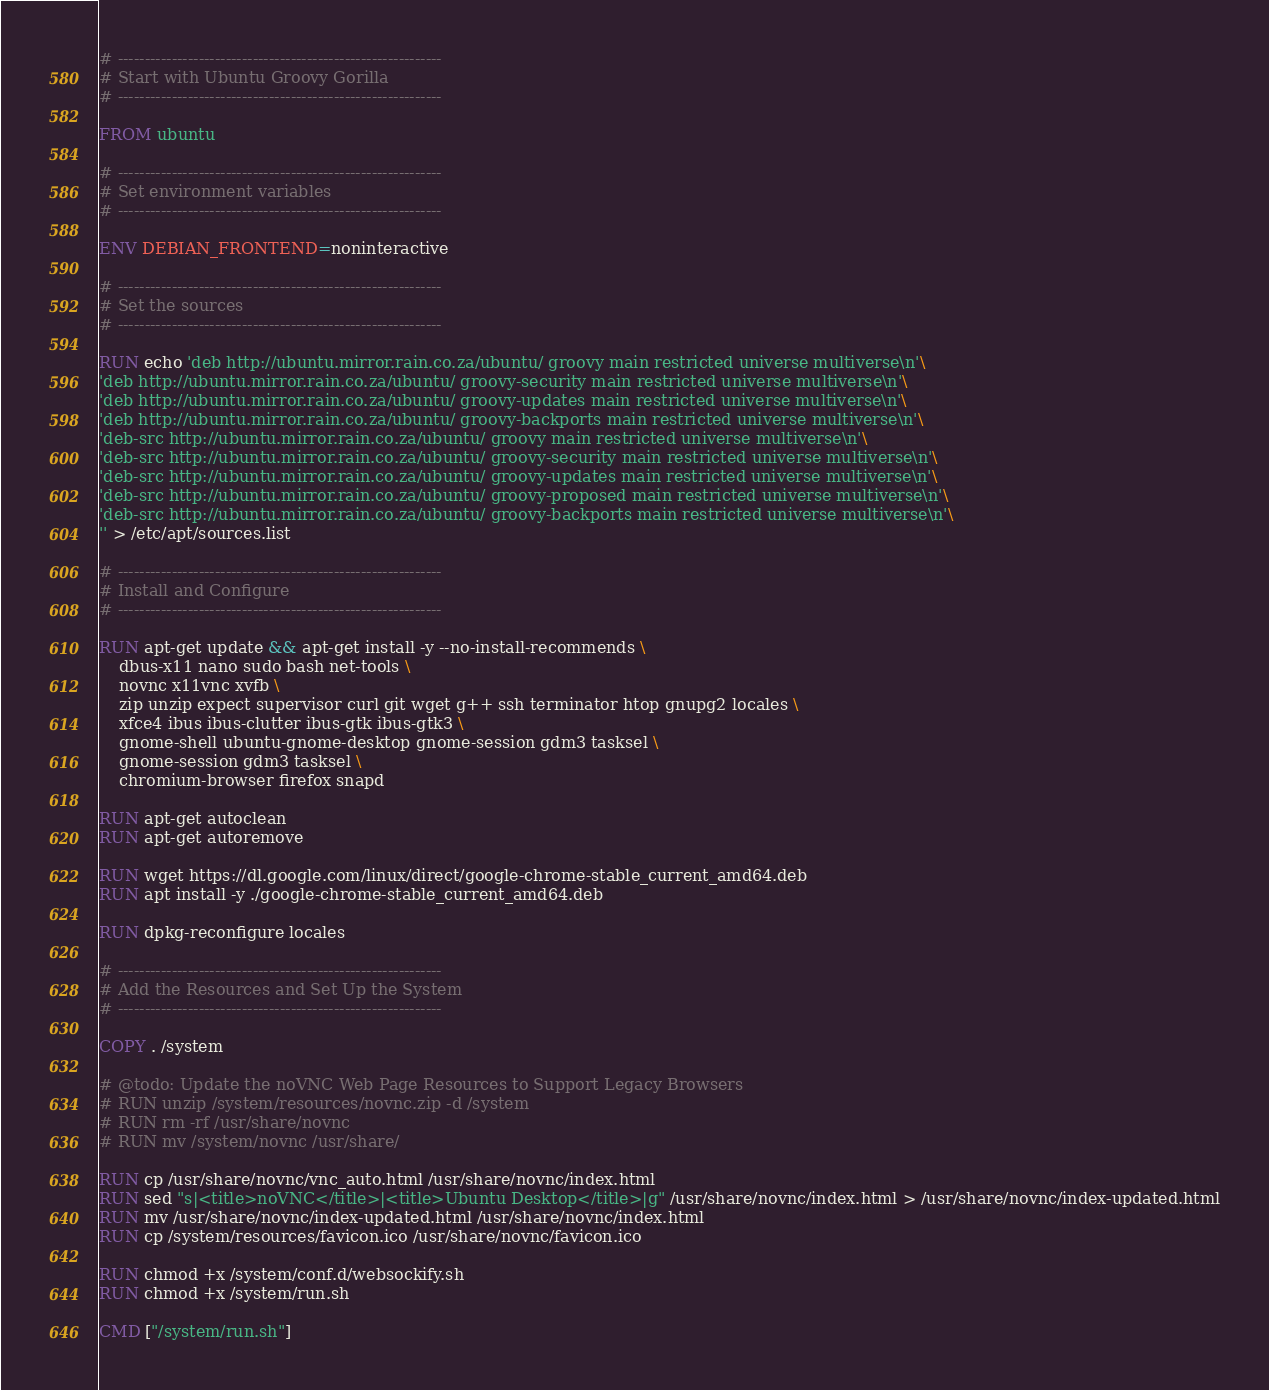Convert code to text. <code><loc_0><loc_0><loc_500><loc_500><_Dockerfile_># ------------------------------------------------------------
# Start with Ubuntu Groovy Gorilla
# ------------------------------------------------------------

FROM ubuntu

# ------------------------------------------------------------
# Set environment variables
# ------------------------------------------------------------

ENV DEBIAN_FRONTEND=noninteractive

# ------------------------------------------------------------
# Set the sources
# ------------------------------------------------------------

RUN echo 'deb http://ubuntu.mirror.rain.co.za/ubuntu/ groovy main restricted universe multiverse\n'\
'deb http://ubuntu.mirror.rain.co.za/ubuntu/ groovy-security main restricted universe multiverse\n'\
'deb http://ubuntu.mirror.rain.co.za/ubuntu/ groovy-updates main restricted universe multiverse\n'\
'deb http://ubuntu.mirror.rain.co.za/ubuntu/ groovy-backports main restricted universe multiverse\n'\
'deb-src http://ubuntu.mirror.rain.co.za/ubuntu/ groovy main restricted universe multiverse\n'\
'deb-src http://ubuntu.mirror.rain.co.za/ubuntu/ groovy-security main restricted universe multiverse\n'\
'deb-src http://ubuntu.mirror.rain.co.za/ubuntu/ groovy-updates main restricted universe multiverse\n'\
'deb-src http://ubuntu.mirror.rain.co.za/ubuntu/ groovy-proposed main restricted universe multiverse\n'\
'deb-src http://ubuntu.mirror.rain.co.za/ubuntu/ groovy-backports main restricted universe multiverse\n'\
'' > /etc/apt/sources.list

# ------------------------------------------------------------
# Install and Configure
# ------------------------------------------------------------

RUN apt-get update && apt-get install -y --no-install-recommends \
    dbus-x11 nano sudo bash net-tools \
    novnc x11vnc xvfb \
    zip unzip expect supervisor curl git wget g++ ssh terminator htop gnupg2 locales \
    xfce4 ibus ibus-clutter ibus-gtk ibus-gtk3 \
    gnome-shell ubuntu-gnome-desktop gnome-session gdm3 tasksel \
    gnome-session gdm3 tasksel \
    chromium-browser firefox snapd

RUN apt-get autoclean
RUN apt-get autoremove

RUN wget https://dl.google.com/linux/direct/google-chrome-stable_current_amd64.deb
RUN apt install -y ./google-chrome-stable_current_amd64.deb

RUN dpkg-reconfigure locales

# ------------------------------------------------------------
# Add the Resources and Set Up the System
# ------------------------------------------------------------

COPY . /system

# @todo: Update the noVNC Web Page Resources to Support Legacy Browsers
# RUN unzip /system/resources/novnc.zip -d /system
# RUN rm -rf /usr/share/novnc
# RUN mv /system/novnc /usr/share/

RUN cp /usr/share/novnc/vnc_auto.html /usr/share/novnc/index.html
RUN sed "s|<title>noVNC</title>|<title>Ubuntu Desktop</title>|g" /usr/share/novnc/index.html > /usr/share/novnc/index-updated.html
RUN mv /usr/share/novnc/index-updated.html /usr/share/novnc/index.html
RUN cp /system/resources/favicon.ico /usr/share/novnc/favicon.ico

RUN chmod +x /system/conf.d/websockify.sh
RUN chmod +x /system/run.sh

CMD ["/system/run.sh"]
</code> 